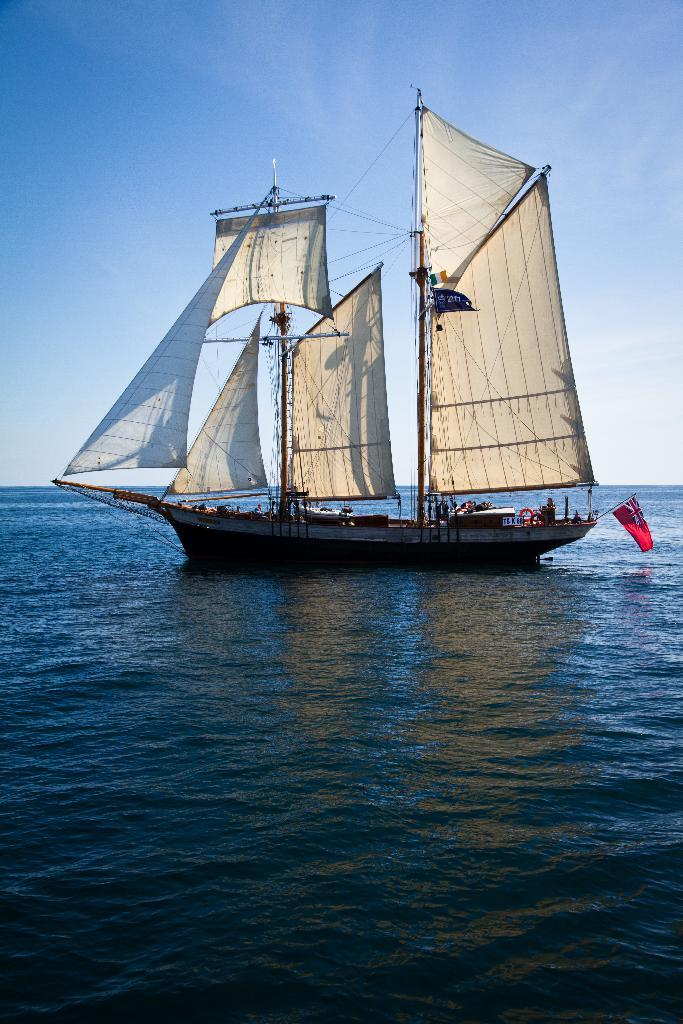What is the main subject of the image? The main subject of the image is water. What is floating on the surface of the water? There is a boat on the surface of the water. What can be seen on the boat? The boat has a red-colored flag. What is visible in the background of the image? The sky is visible in the background of the image. What is the name of the attraction near the boat in the image? There is no specific attraction mentioned or visible in the image, so it is not possible to determine its name. Can you tell me which button on the boat controls the speed? There are no buttons visible on the boat in the image, so it is not possible to determine which one controls the speed. 